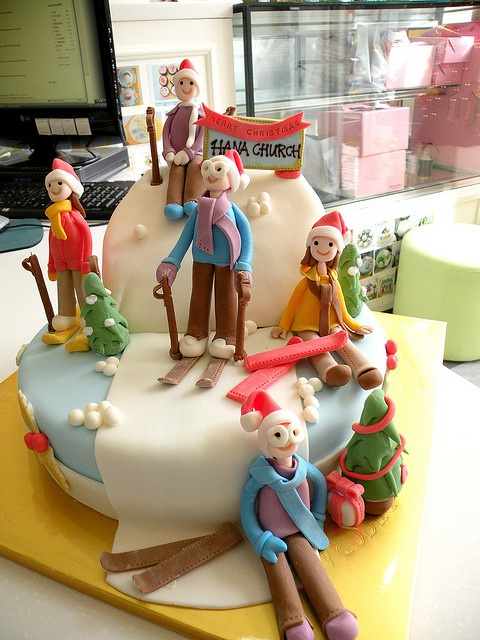Describe the objects in this image and their specific colors. I can see cake in darkgreen, tan, ivory, darkgray, and maroon tones, tv in darkgreen, black, and olive tones, skis in darkgreen, maroon, gray, and brown tones, keyboard in darkgreen, black, gray, and darkgray tones, and skis in darkgreen, salmon, and red tones in this image. 